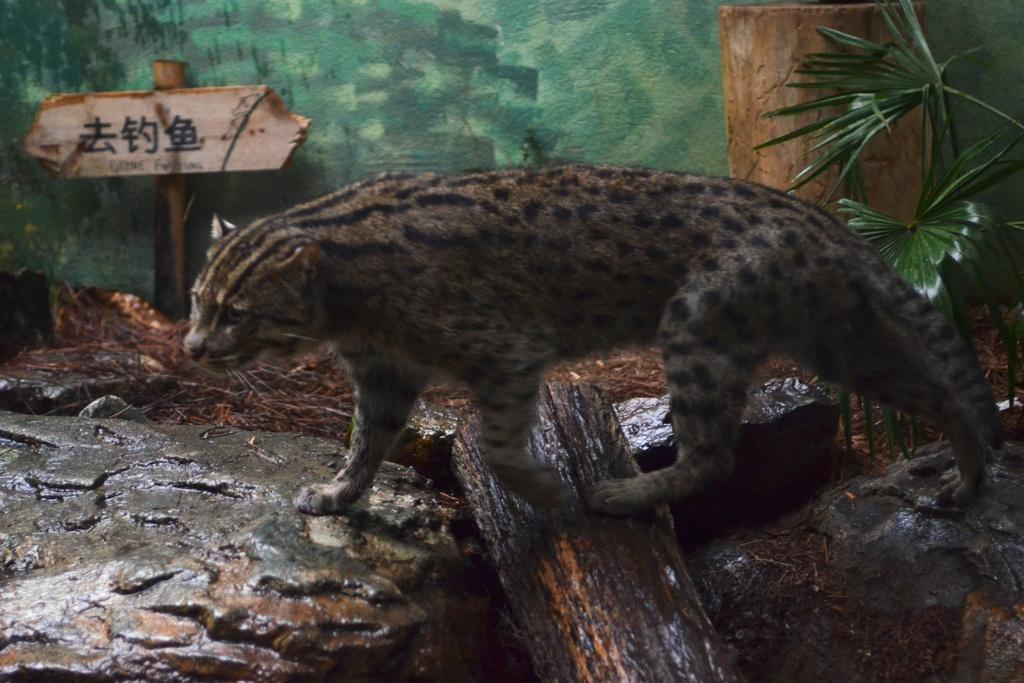What is the main subject in the center of the image? There is an animal in the center of the image. What is located at the bottom of the image? There is a tree trunk at the bottom of the image. What can be seen in the background of the image? There is a wall and a sign board in the background of the image. How many houses are depicted in the image? There are no houses present in the image. What type of shape is the animal forming in the image? The animal's shape cannot be determined from the image alone, as it is not a flat image. 